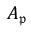Convert formula to latex. <formula><loc_0><loc_0><loc_500><loc_500>A _ { \mathfrak { p } }</formula> 